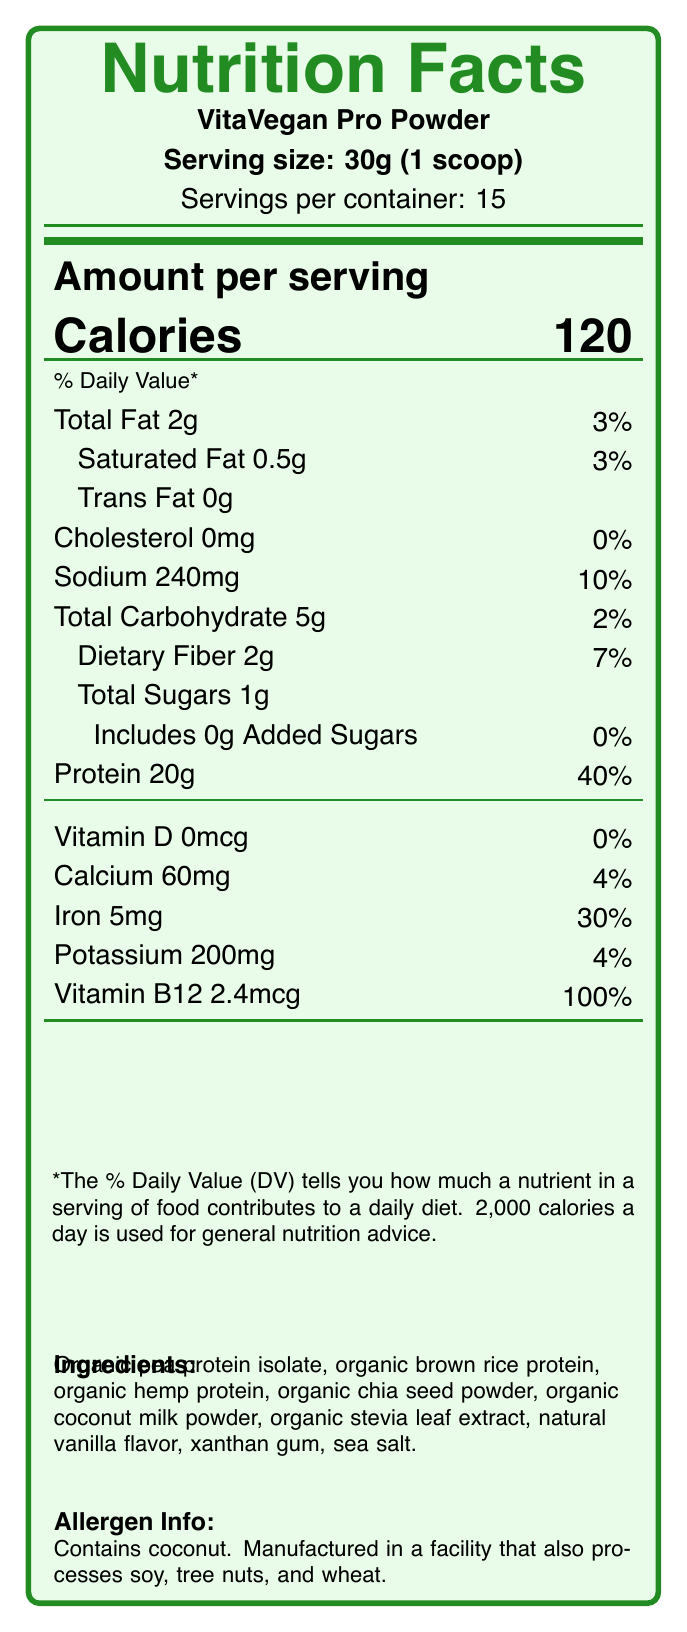what is the serving size? The document clearly states that the serving size is 30g (1 scoop).
Answer: 30g (1 scoop) how many servings are there per container? The document indicates that there are 15 servings per container.
Answer: 15 how many calories are in one serving? The document mentions that there are 120 calories per serving.
Answer: 120 what is the amount of protein in one serving? The document states that there are 20g of protein per serving.
Answer: 20g what is the daily value percentage of iron? The document notes that each serving provides 30% of the daily value for iron.
Answer: 30% which ingredient is not listed in the ingredient list? A. Organic stevia leaf extract B. Organic pea protein isolate C. Whey protein D. Xanthan gum The ingredient 'Whey protein' is not found in the listed ingredients, whereas the others are.
Answer: C. Whey protein what is the source of sweetness in the product? A. Organic cane sugar B. Organic honey C. Organic stevia leaf extract D. High-fructose corn syrup The document lists 'Organic stevia leaf extract' as one of the ingredients.
Answer: C. Organic stevia leaf extract is the product container recyclable? The document states that the packaging is a 100% recyclable container made from post-consumer recycled materials.
Answer: Yes does this product contain any added sugars? The document specifies that there are 0g of added sugars in the product.
Answer: No summarize the key nutritional and ethical aspects of the document. This summary encapsulates the primary nutritional data along with the ethical and sociological aspects that the product emphasizes.
Answer: The document provides Nutrition Facts for VitaVegan Pro Powder, detailing its serving size, calorie content, and daily values of various nutrients. Ethically, it highlights the use of ethically sourced ingredients, fair trade practices, support for local organic farmers, and a carbon-neutral manufacturing process, targeting health-conscious millennials aged 25-38. where is this product manufactured? The document does not provide information about the location of the manufacturing facility.
Answer: Not enough information 